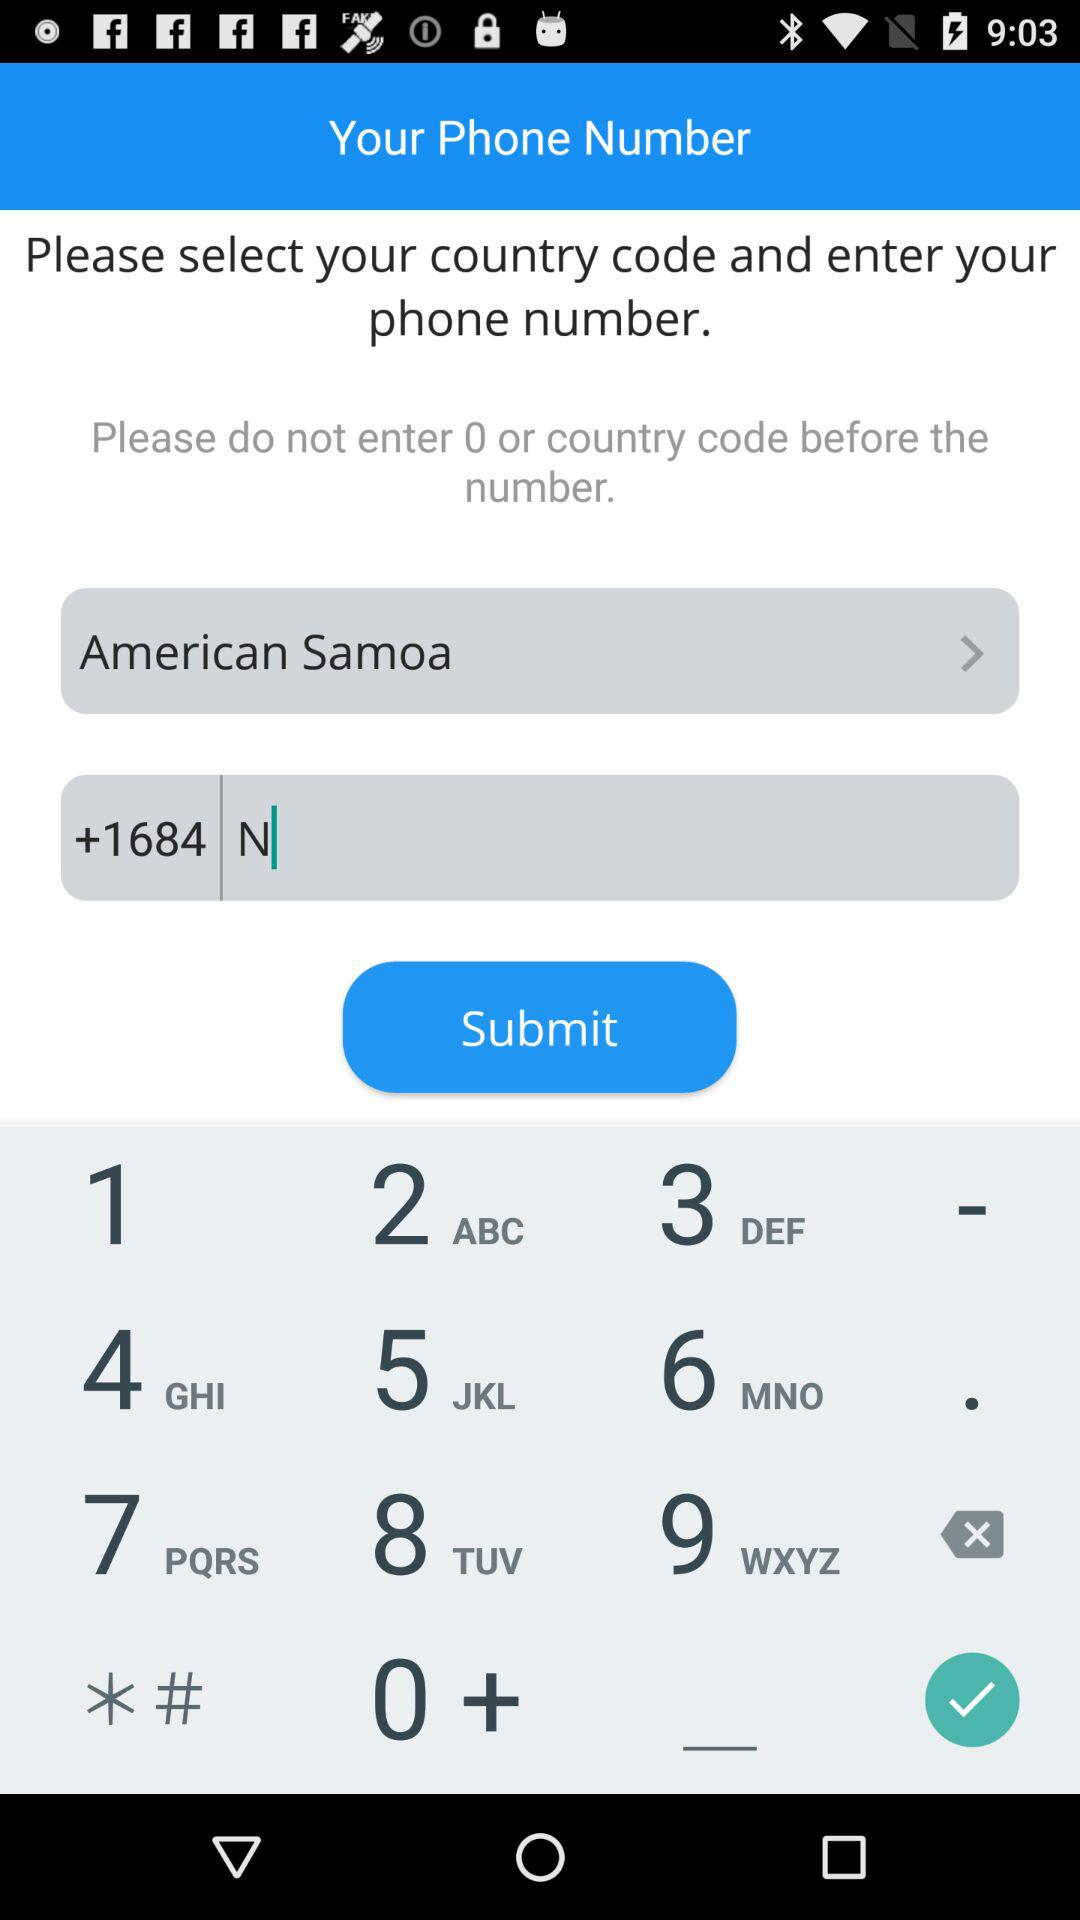What's the country name? The country name is American Samoa. 